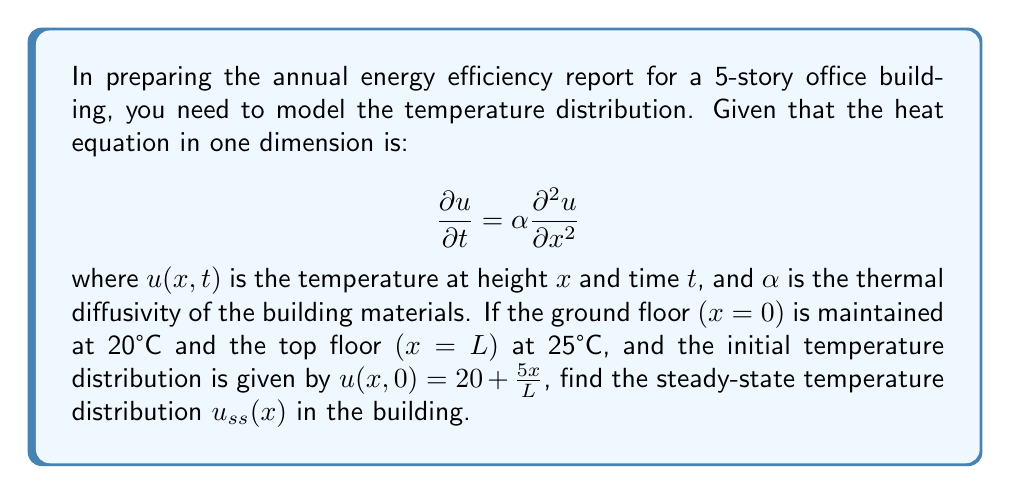Can you solve this math problem? To solve this problem, we'll follow these steps:

1) For the steady-state solution, the temperature doesn't change with time, so $\frac{\partial u}{\partial t} = 0$. The heat equation becomes:

   $$0 = \alpha \frac{d^2 u_{ss}}{dx^2}$$

2) Integrating twice with respect to $x$:

   $$u_{ss}(x) = Ax + B$$

   where $A$ and $B$ are constants to be determined.

3) Apply the boundary conditions:
   - At $x=0$: $u_{ss}(0) = 20°C$, so $B = 20$
   - At $x=L$: $u_{ss}(L) = 25°C$, so $AL + 20 = 25$

4) Solve for $A$:

   $$A = \frac{25-20}{L} = \frac{5}{L}$$

5) Therefore, the steady-state temperature distribution is:

   $$u_{ss}(x) = \frac{5x}{L} + 20$$

This is a linear function that increases from 20°C at the ground floor to 25°C at the top floor, regardless of the initial temperature distribution or the thermal properties of the building materials.
Answer: $u_{ss}(x) = \frac{5x}{L} + 20$ 